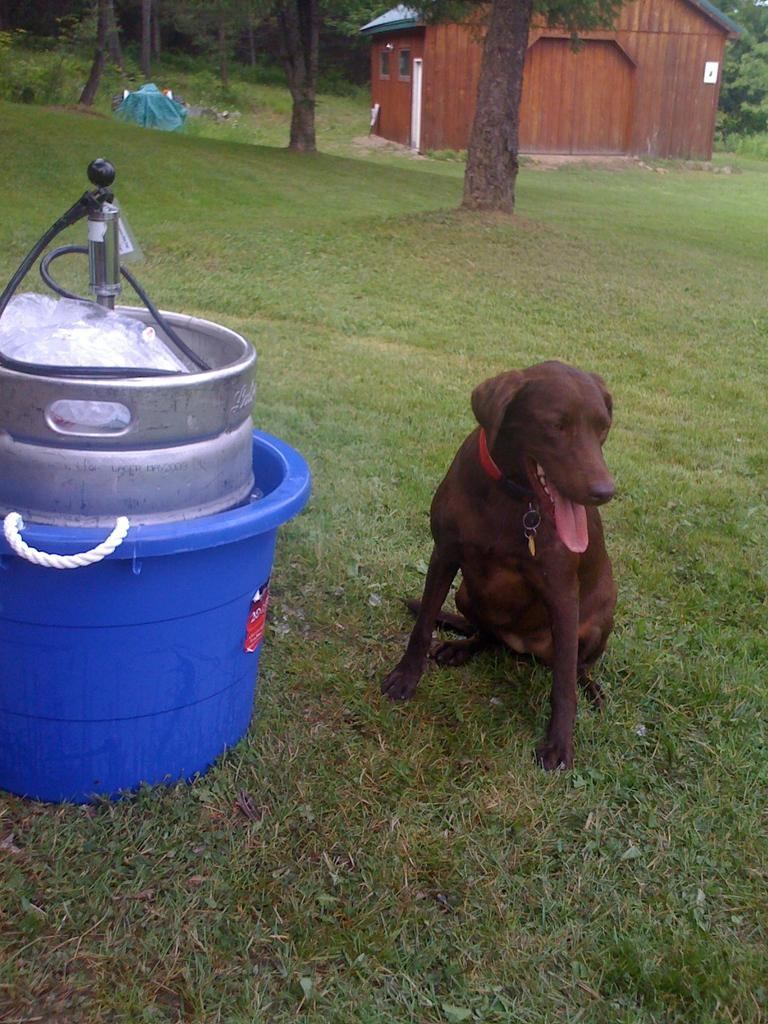What animal can be seen in the image? There is a dog in the image. Where is the dog located? The dog is on the grass. What is present in the tub on the left side of the image? There is an object in a tub on the left side of the image. What can be seen in the background of the image? There is a house and trees in the background of the image. What type of body is visible in the image? There is no body present in the image; it features a dog on the grass, an object in a tub, and a background with a house and trees. What kind of drug can be seen in the image? There is no drug present in the image. 